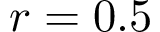<formula> <loc_0><loc_0><loc_500><loc_500>r = 0 . 5</formula> 